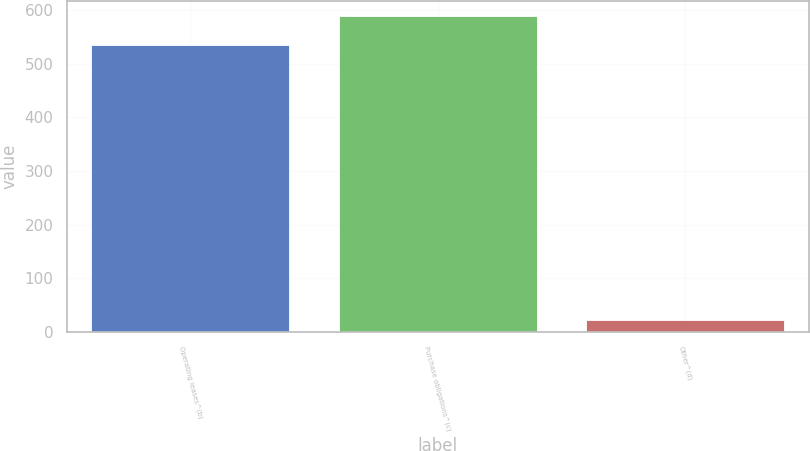Convert chart. <chart><loc_0><loc_0><loc_500><loc_500><bar_chart><fcel>Operating leases^(b)<fcel>Purchase obligations^(c)<fcel>Other^(d)<nl><fcel>535<fcel>587.9<fcel>22<nl></chart> 